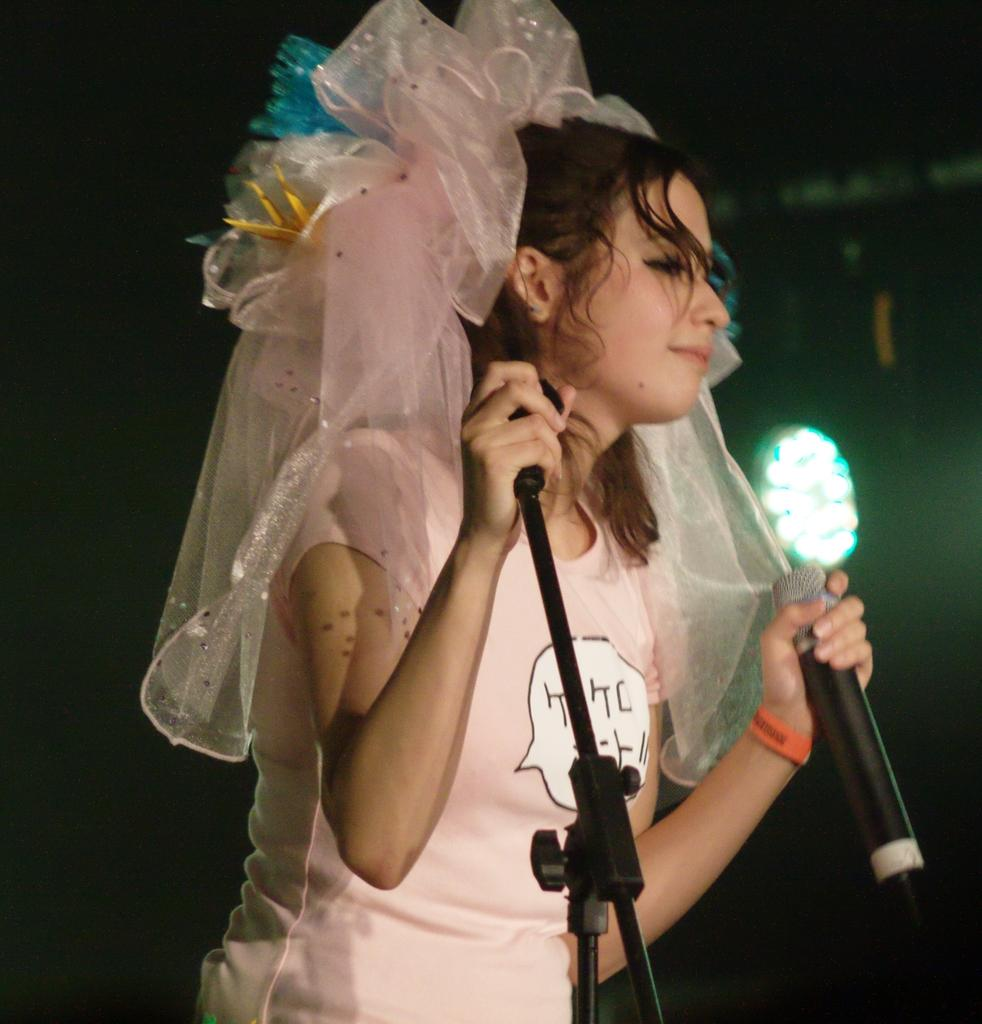Who is the main subject in the image? There is a lady in the image. What is the lady wearing? The lady is wearing a pick t-shirt. What is the lady holding in the image? The lady is holding a microphone. Which hand of the lady is visible in the image? The lady's left hand is visible. What is the lady's facial expression in the image? The lady is smiling. How many visitors are present in the room in the image? There is no room or visitors present in the image; it features a lady holding a microphone. 